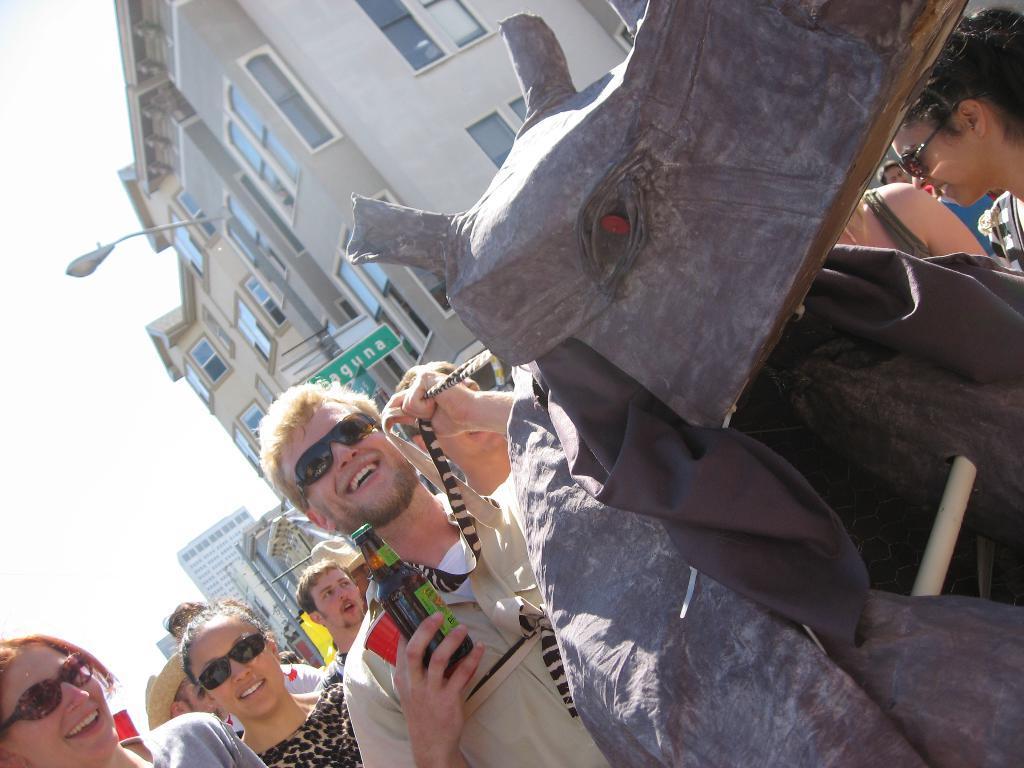Please provide a concise description of this image. In this image there are few people standing on the road. There is a man in the middle who is holding the glass bottle with one hand and a mask with another hand. In the background there are buildings with the windows. There is a light pole on the footpath. To the pole there is a board. 